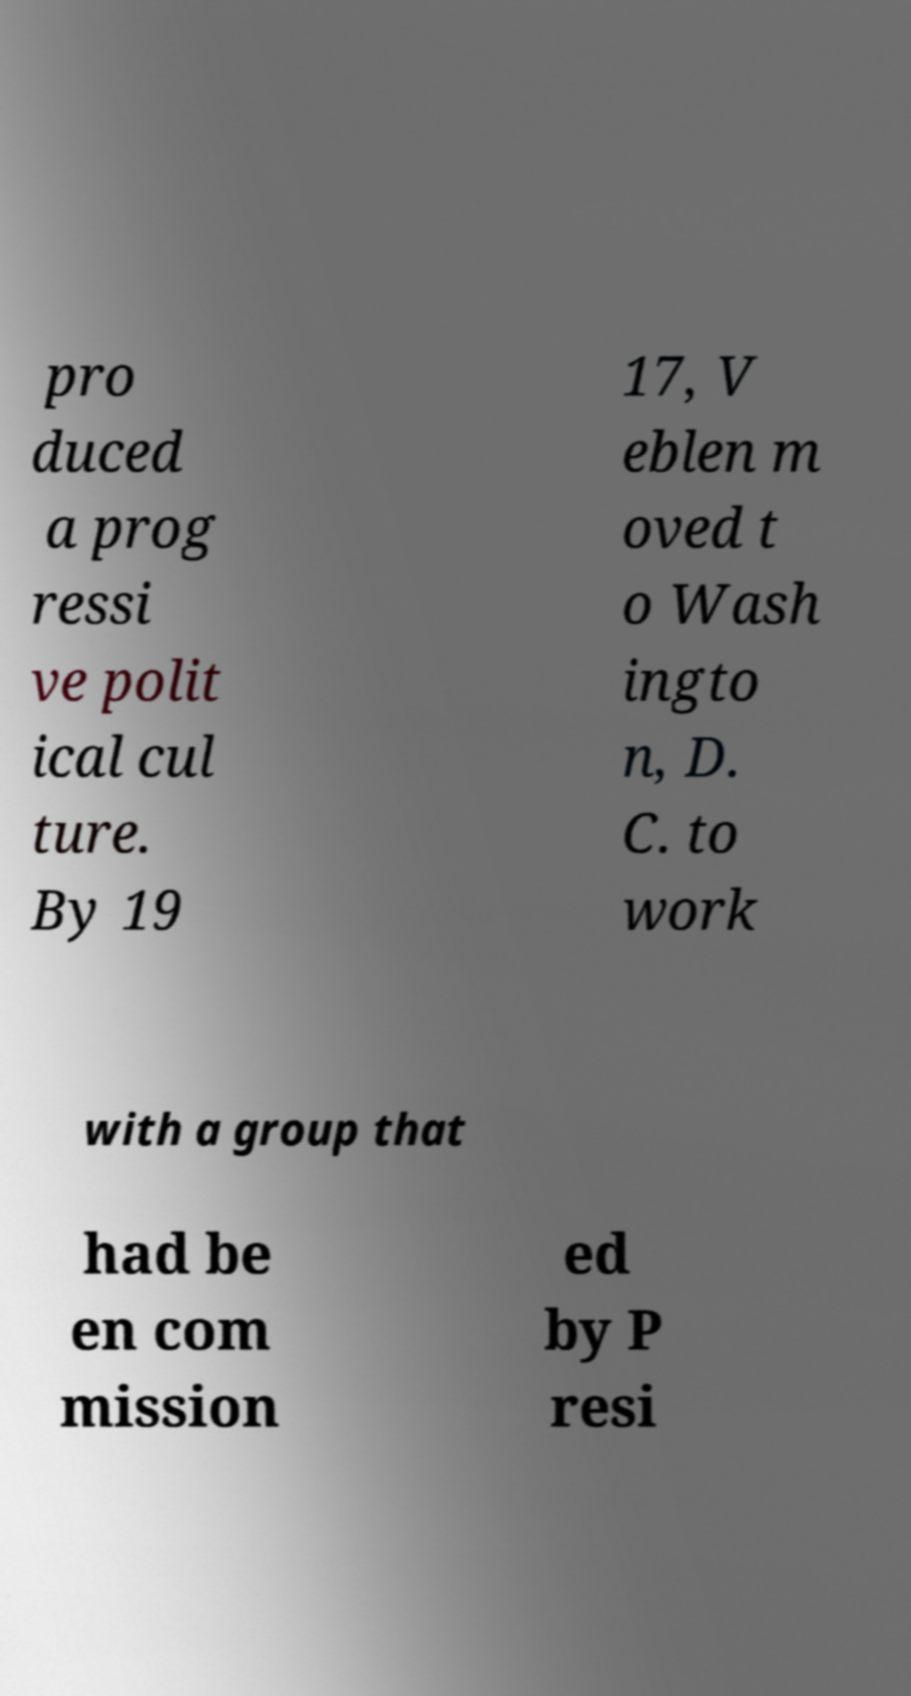For documentation purposes, I need the text within this image transcribed. Could you provide that? pro duced a prog ressi ve polit ical cul ture. By 19 17, V eblen m oved t o Wash ingto n, D. C. to work with a group that had be en com mission ed by P resi 